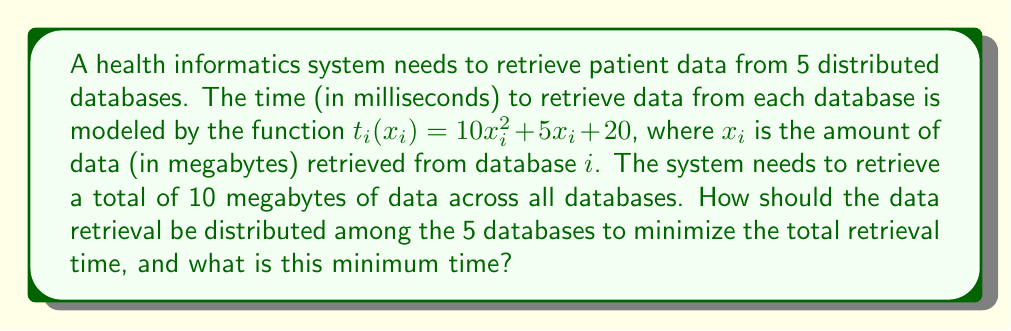Solve this math problem. To solve this optimization problem, we can use the method of Lagrange multipliers. Let's approach this step-by-step:

1) First, we need to set up our objective function and constraint:

   Objective function: $T = \sum_{i=1}^5 (10x_i^2 + 5x_i + 20)$
   Constraint: $\sum_{i=1}^5 x_i = 10$

2) We form the Lagrangian:

   $L = \sum_{i=1}^5 (10x_i^2 + 5x_i + 20) - \lambda(\sum_{i=1}^5 x_i - 10)$

3) We take partial derivatives with respect to each $x_i$ and $\lambda$:

   $\frac{\partial L}{\partial x_i} = 20x_i + 5 - \lambda = 0$ for $i = 1, 2, 3, 4, 5$
   $\frac{\partial L}{\partial \lambda} = \sum_{i=1}^5 x_i - 10 = 0$

4) From the first equation, we can see that all $x_i$ are equal:

   $x_i = \frac{\lambda - 5}{20}$ for all $i$

5) Substituting this into the constraint equation:

   $5(\frac{\lambda - 5}{20}) = 10$

6) Solving for $\lambda$:

   $\lambda - 5 = 40$
   $\lambda = 45$

7) Now we can find $x_i$:

   $x_i = \frac{45 - 5}{20} = 2$ for all $i$

8) The minimum total time is:

   $T_{min} = 5(10(2)^2 + 5(2) + 20) = 5(40 + 10 + 20) = 350$

Therefore, the optimal distribution is to retrieve 2 megabytes from each database, and the minimum total retrieval time is 350 milliseconds.
Answer: Optimal distribution: 2 megabytes from each database
Minimum total retrieval time: 350 milliseconds 